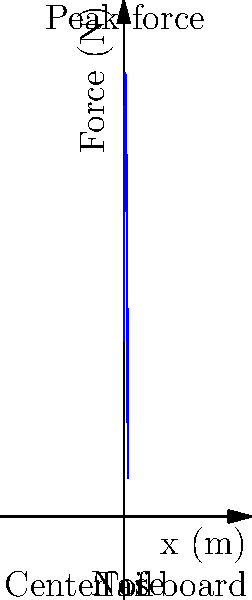Based on the force distribution graph for an ollie trick on a skateboard, at approximately what position along the board (in meters) does the peak force occur? To determine the position of peak force during an ollie:

1. Observe the graph: It shows force distribution along the length of a skateboard.
2. The x-axis represents the board's length (0 to 1 meter).
3. The y-axis represents the force applied.
4. Look for the highest point on the curve.
5. The highest point occurs at approximately x = 0.3 meters.
6. This position corresponds to the area just behind the front trucks.
7. During an ollie, the skater applies maximum force here to pop the board.

The peak force occurs at approximately 0.3 meters from the tail of the skateboard.
Answer: 0.3 meters 